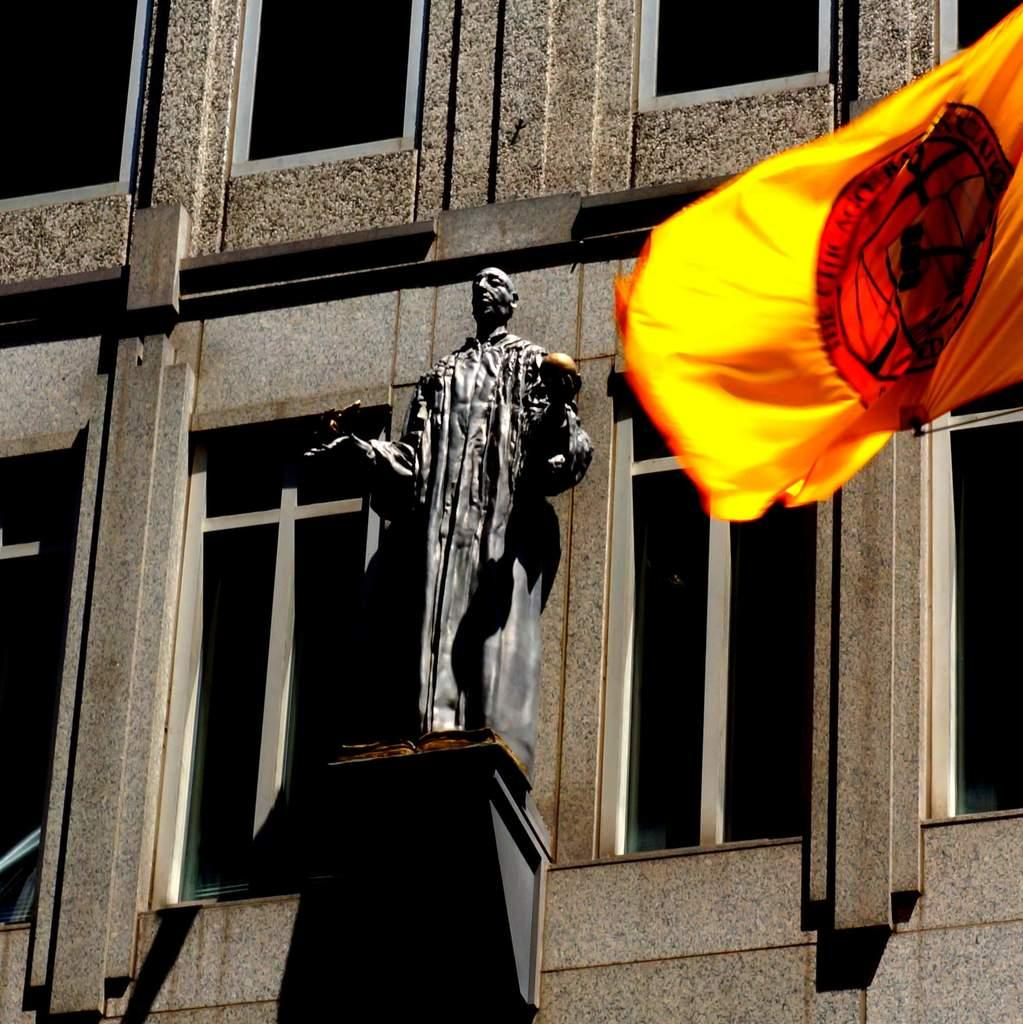What is the main subject in the middle of the image? There is a statue in the middle of the image. What can be seen in the background of the image? There is a building in the background of the image. Where is the flag located in the image? The flag is on the top right side of the image. What type of credit card is being used by the statue in the image? There is no credit card or any indication of a financial transaction in the image; the main subject is a statue. 